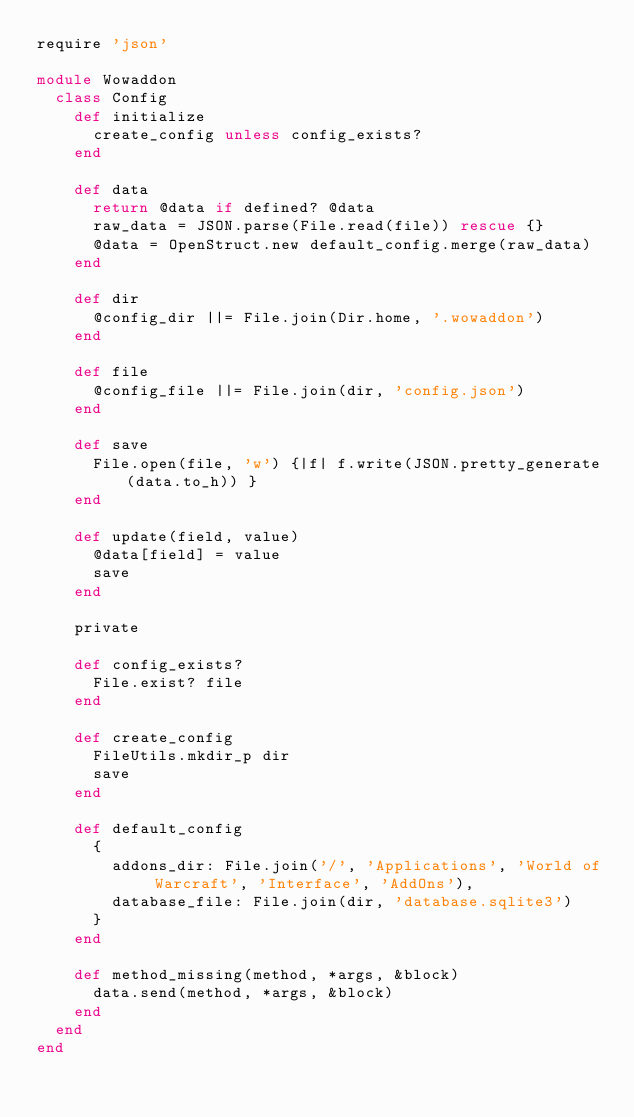<code> <loc_0><loc_0><loc_500><loc_500><_Ruby_>require 'json'

module Wowaddon
  class Config
    def initialize
      create_config unless config_exists?
    end

    def data
      return @data if defined? @data
      raw_data = JSON.parse(File.read(file)) rescue {}
      @data = OpenStruct.new default_config.merge(raw_data)
    end

    def dir
      @config_dir ||= File.join(Dir.home, '.wowaddon')
    end

    def file
      @config_file ||= File.join(dir, 'config.json')
    end

    def save
      File.open(file, 'w') {|f| f.write(JSON.pretty_generate(data.to_h)) }
    end

    def update(field, value)
      @data[field] = value
      save
    end

    private

    def config_exists?
      File.exist? file
    end

    def create_config
      FileUtils.mkdir_p dir
      save
    end

    def default_config
      {
        addons_dir: File.join('/', 'Applications', 'World of Warcraft', 'Interface', 'AddOns'),
        database_file: File.join(dir, 'database.sqlite3')
      }
    end

    def method_missing(method, *args, &block)
      data.send(method, *args, &block)
    end
  end
end
</code> 